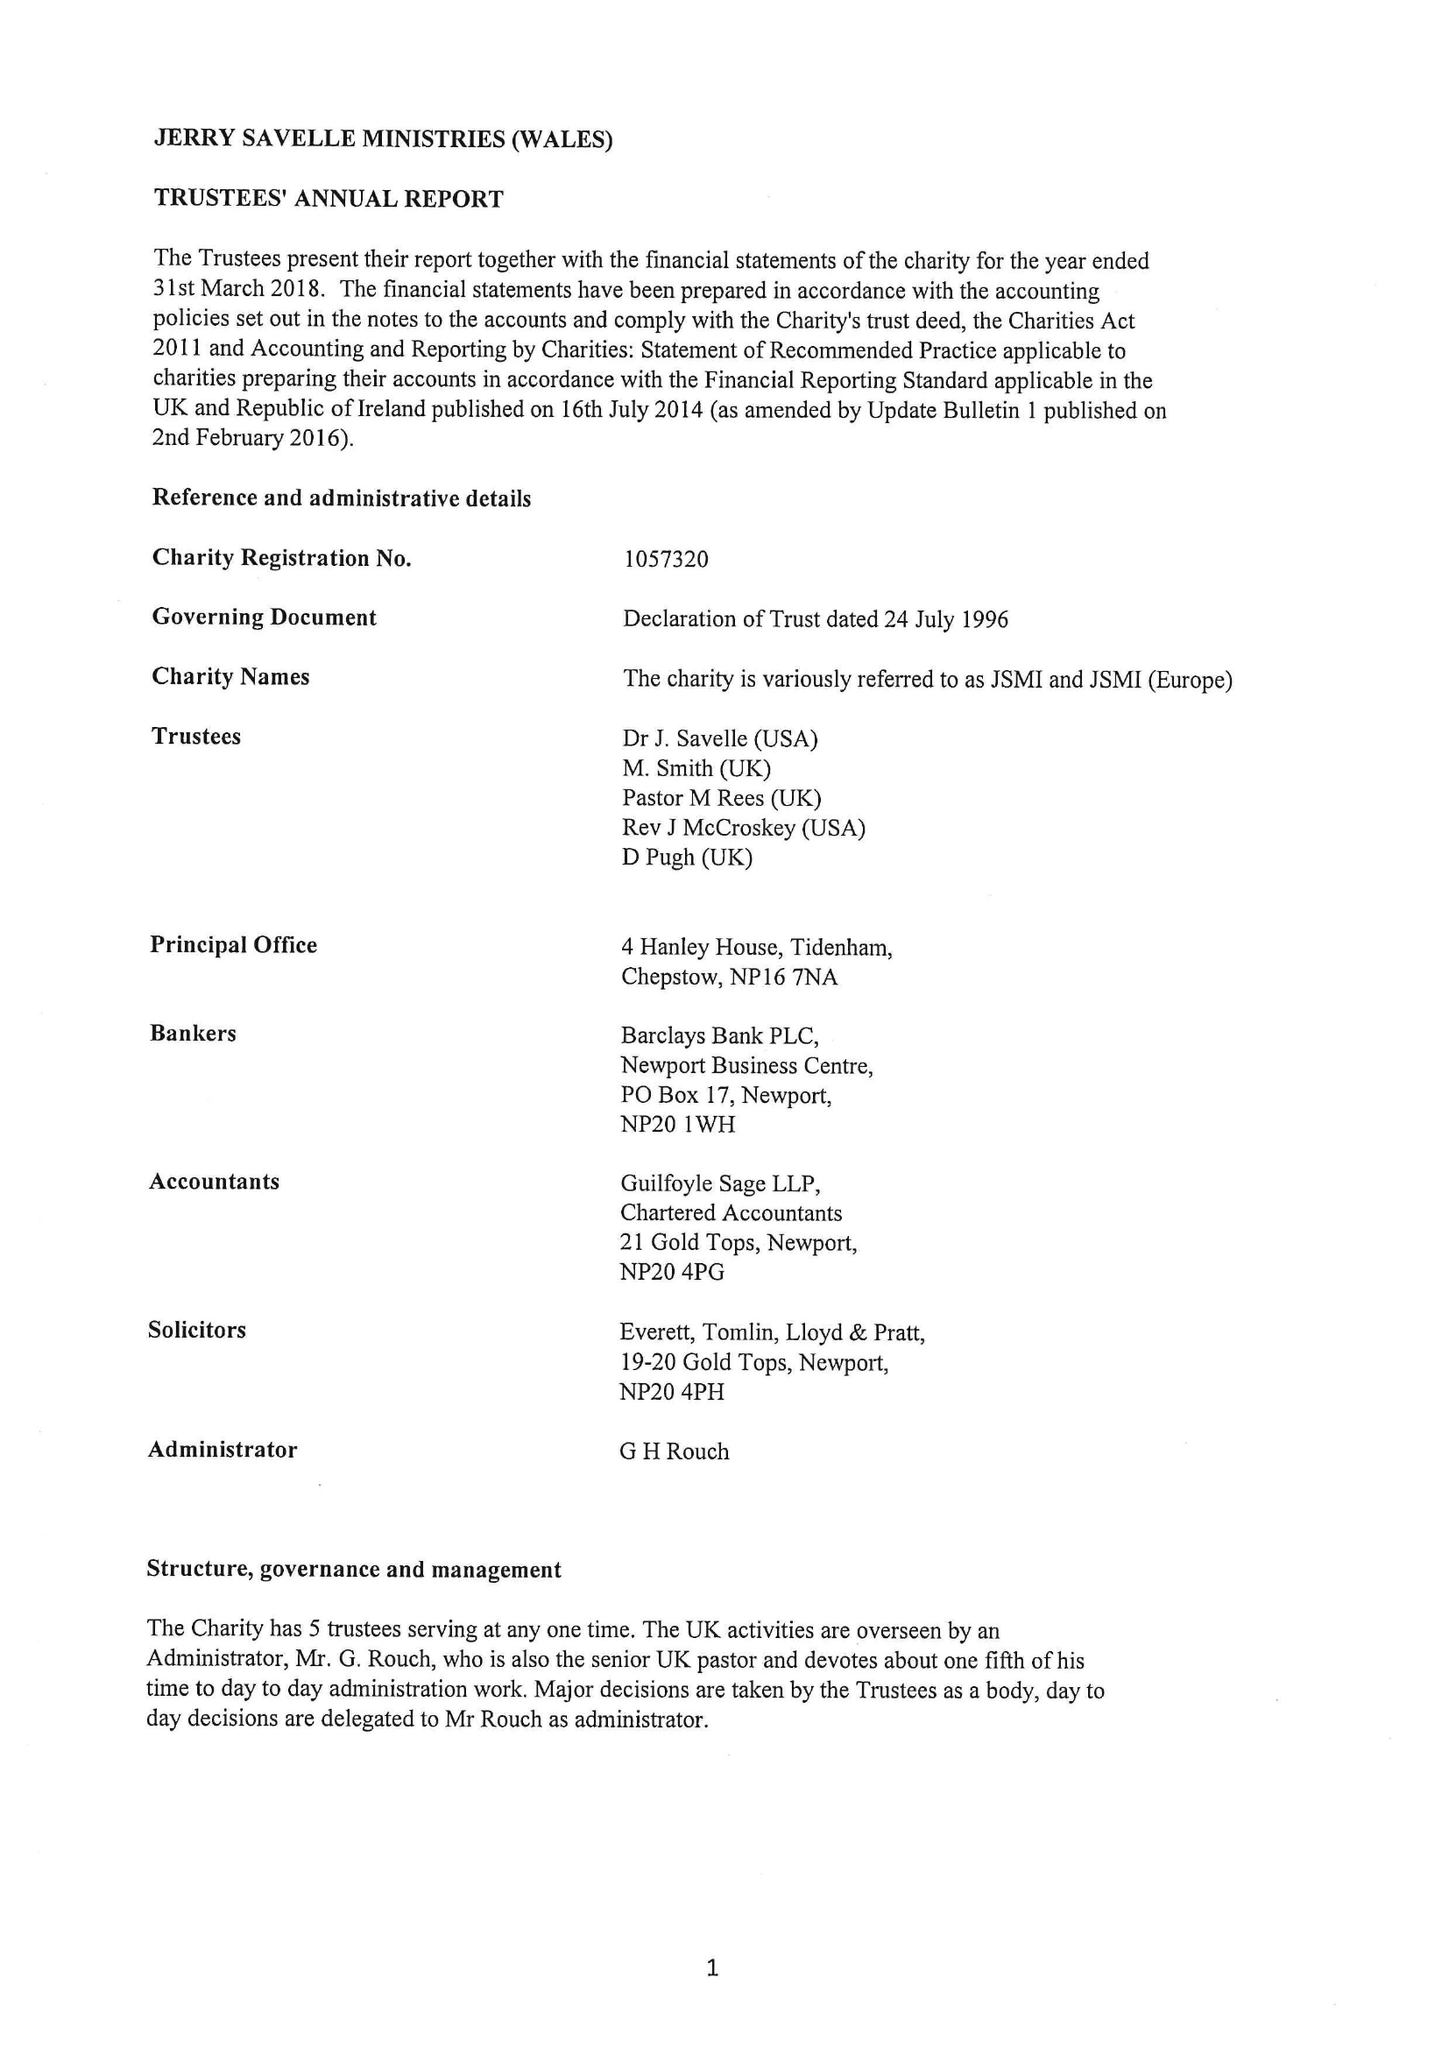What is the value for the address__post_town?
Answer the question using a single word or phrase. CHEPSTOW 